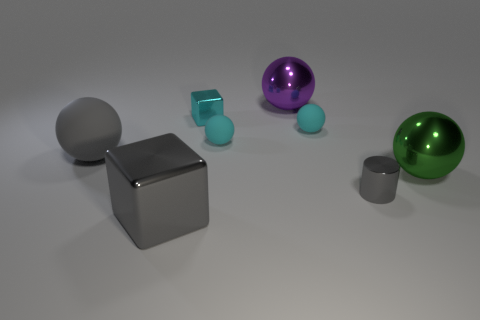Subtract all big green spheres. How many spheres are left? 4 Add 1 large metal things. How many objects exist? 9 Subtract all purple spheres. How many spheres are left? 4 Subtract all brown blocks. How many cyan balls are left? 2 Subtract 1 cubes. How many cubes are left? 1 Subtract all spheres. How many objects are left? 3 Subtract all green cylinders. Subtract all brown cubes. How many cylinders are left? 1 Subtract all big gray rubber balls. Subtract all cylinders. How many objects are left? 6 Add 8 small cyan metal blocks. How many small cyan metal blocks are left? 9 Add 6 tiny gray cylinders. How many tiny gray cylinders exist? 7 